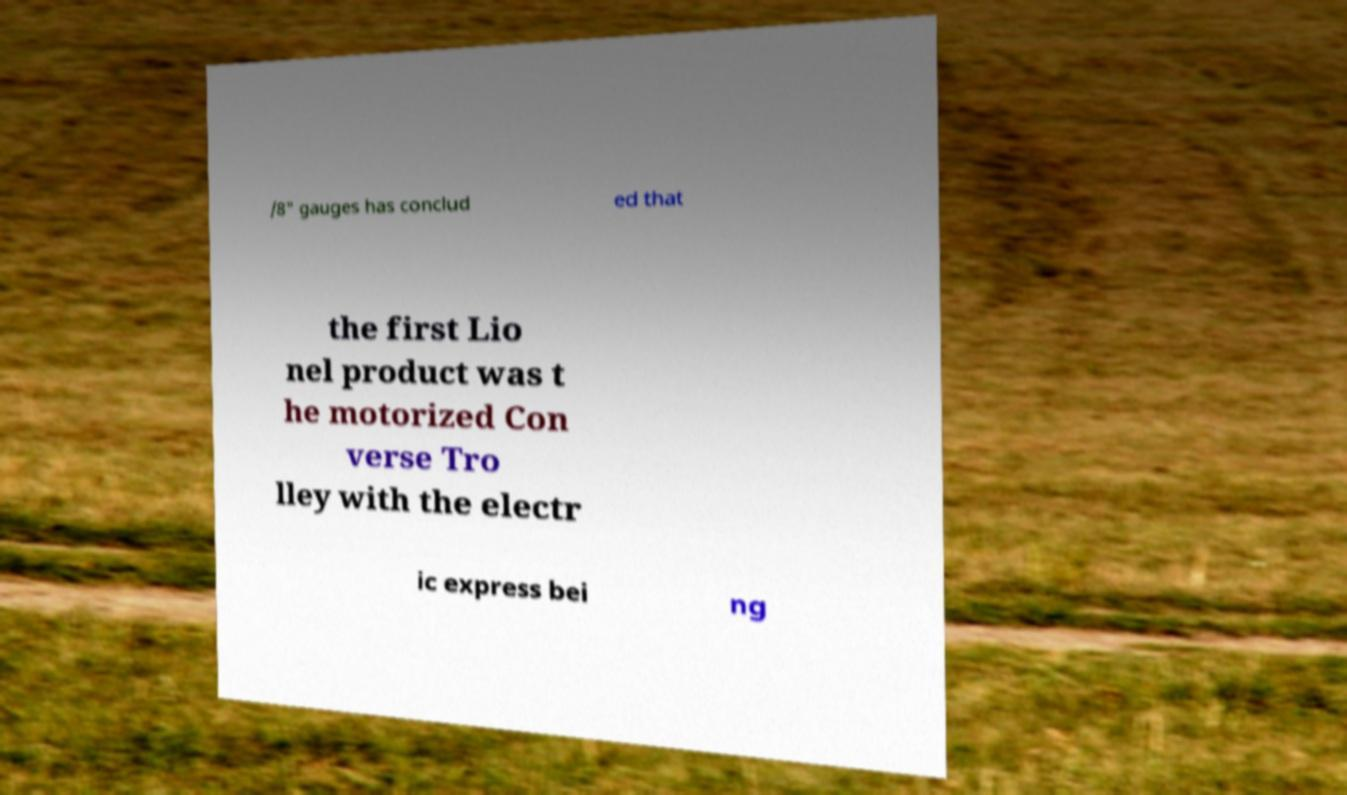Can you read and provide the text displayed in the image?This photo seems to have some interesting text. Can you extract and type it out for me? /8" gauges has conclud ed that the first Lio nel product was t he motorized Con verse Tro lley with the electr ic express bei ng 